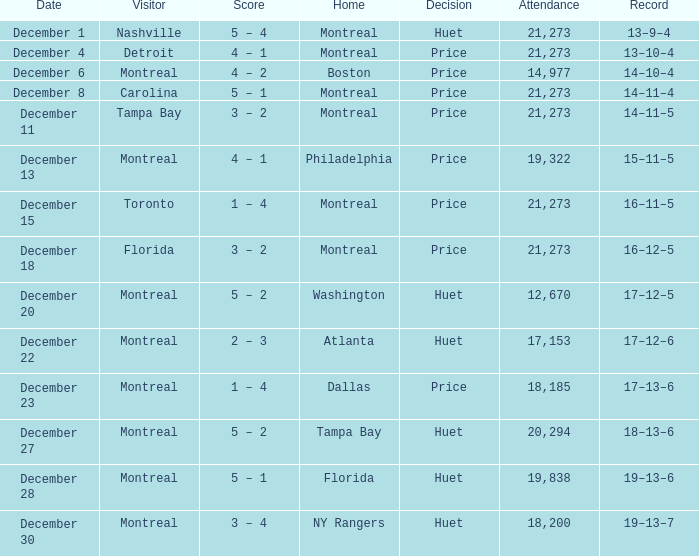What notable occurrence took place on december 4? 13–10–4. 